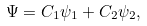Convert formula to latex. <formula><loc_0><loc_0><loc_500><loc_500>\Psi = C _ { 1 } \psi _ { 1 } + C _ { 2 } \psi _ { 2 } ,</formula> 